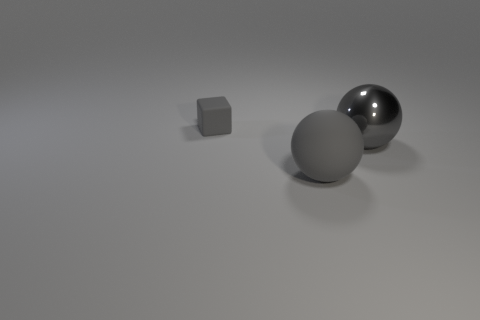Add 2 big gray matte objects. How many objects exist? 5 Subtract all cyan balls. Subtract all green blocks. How many balls are left? 2 Subtract all tiny gray rubber cubes. Subtract all large cyan rubber cylinders. How many objects are left? 2 Add 2 shiny balls. How many shiny balls are left? 3 Add 1 matte things. How many matte things exist? 3 Subtract 0 brown spheres. How many objects are left? 3 Subtract all balls. How many objects are left? 1 Subtract 2 balls. How many balls are left? 0 